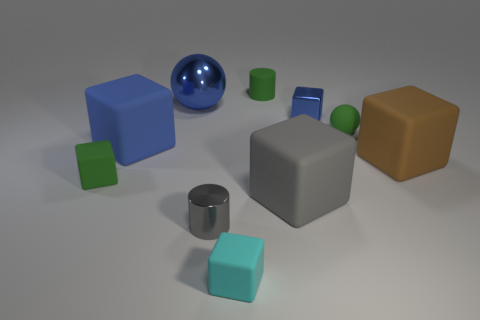Subtract all blue blocks. How many were subtracted if there are1blue blocks left? 1 Subtract 1 cubes. How many cubes are left? 5 Subtract all gray cubes. How many cubes are left? 5 Subtract all gray rubber cubes. How many cubes are left? 5 Subtract all red blocks. Subtract all gray cylinders. How many blocks are left? 6 Subtract all balls. How many objects are left? 8 Add 1 small cyan cylinders. How many small cyan cylinders exist? 1 Subtract 0 yellow blocks. How many objects are left? 10 Subtract all tiny gray objects. Subtract all big blue objects. How many objects are left? 7 Add 9 tiny gray cylinders. How many tiny gray cylinders are left? 10 